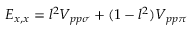Convert formula to latex. <formula><loc_0><loc_0><loc_500><loc_500>E _ { x , x } = l ^ { 2 } V _ { p p \sigma } + ( 1 - l ^ { 2 } ) V _ { p p \pi }</formula> 